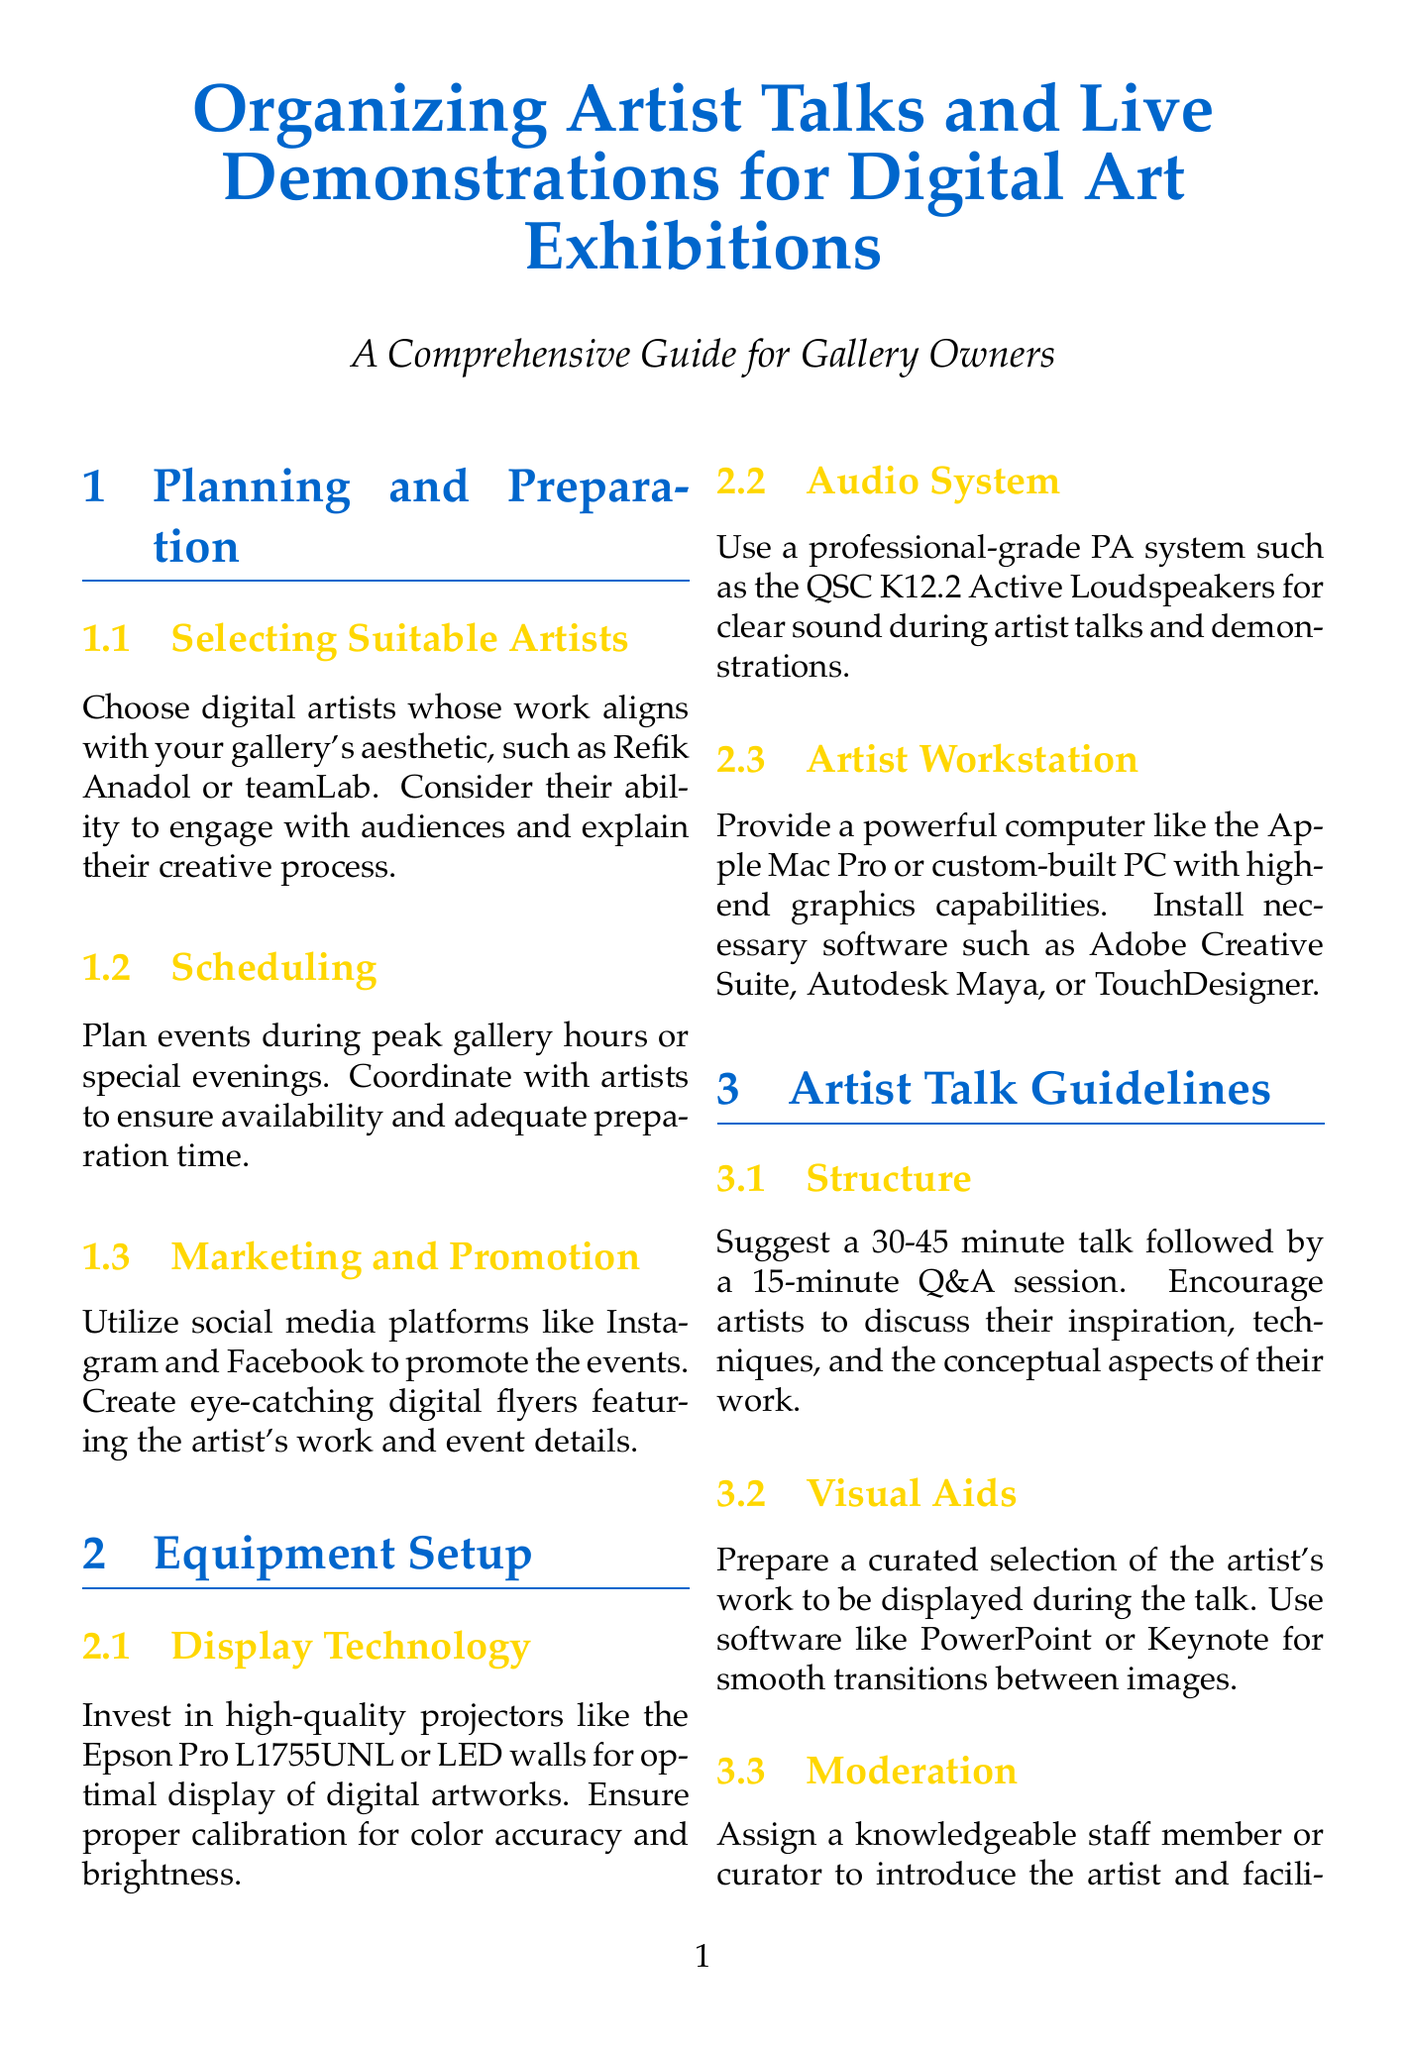What is the title of the document? The title is clearly stated at the top of the document, indicating the main focus.
Answer: Organizing Artist Talks and Live Demonstrations for Digital Art Exhibitions Who are suggested digital artists to select? The document lists specific artists that align with the gallery's aesthetic in the planning section.
Answer: Refik Anadol or teamLab What is the recommended duration for an artist talk? The structure suggests a specific time frame for artist talks followed by Q&A.
Answer: 30-45 minutes How many minutes should live demonstrations be limited to? It states a maximum time limit for live demonstrations to keep the audience engaged.
Answer: 60-90 minutes Which audio system is recommended for clear sound? The equipment setup section identifies a professional-grade audio system for optimal sound.
Answer: QSC K12.2 Active Loudspeakers What type of displays should be set up for interactive elements? This part of the document specifies devices that can be used for audience interaction.
Answer: Touchscreen displays or VR stations Which software is suggested for video editing? The post-event considerations mention specific software for creating promotional clips.
Answer: Adobe Premiere Pro What type of token of appreciation should be provided to the artist? The document states a specific type of gift to show appreciation to artists post-event.
Answer: Limited edition print of their work 